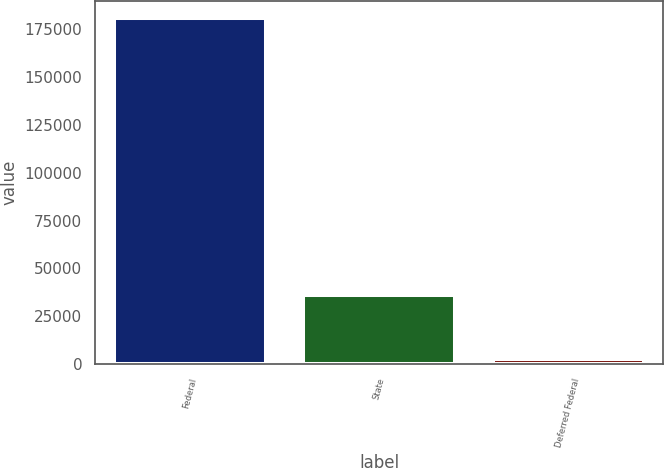Convert chart. <chart><loc_0><loc_0><loc_500><loc_500><bar_chart><fcel>Federal<fcel>State<fcel>Deferred Federal<nl><fcel>180895<fcel>36142<fcel>2681<nl></chart> 